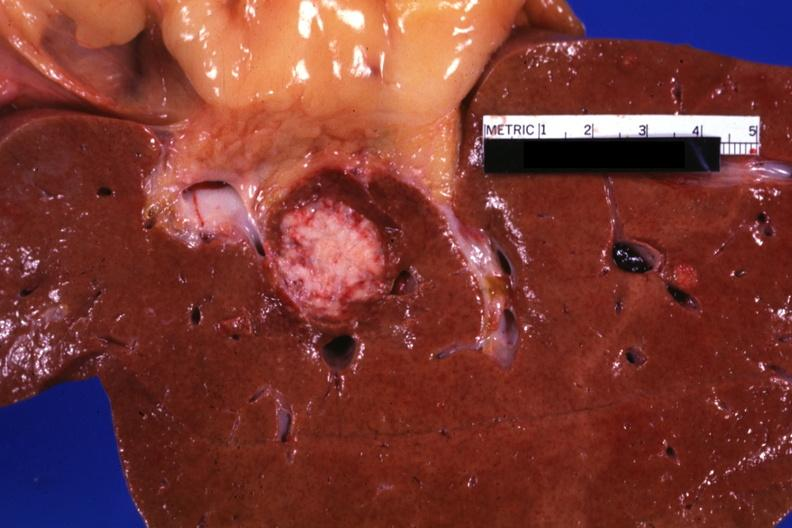s liver present?
Answer the question using a single word or phrase. Yes 